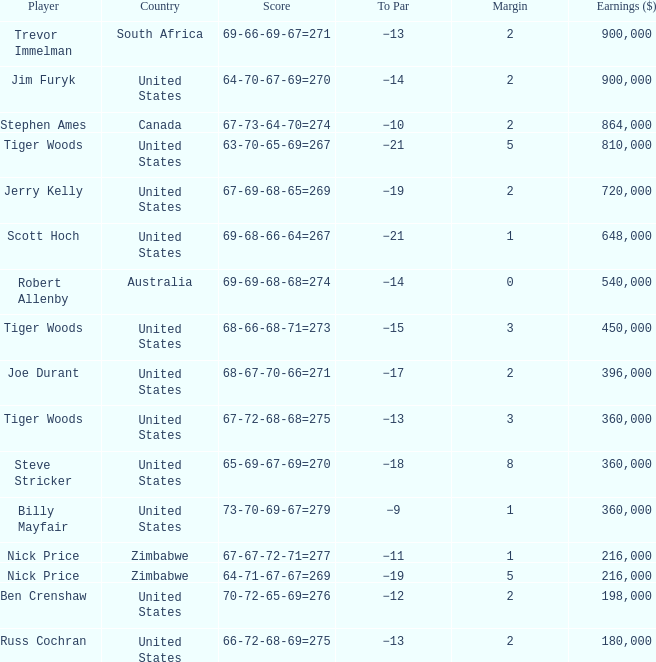What is canada's margin? 2.0. 